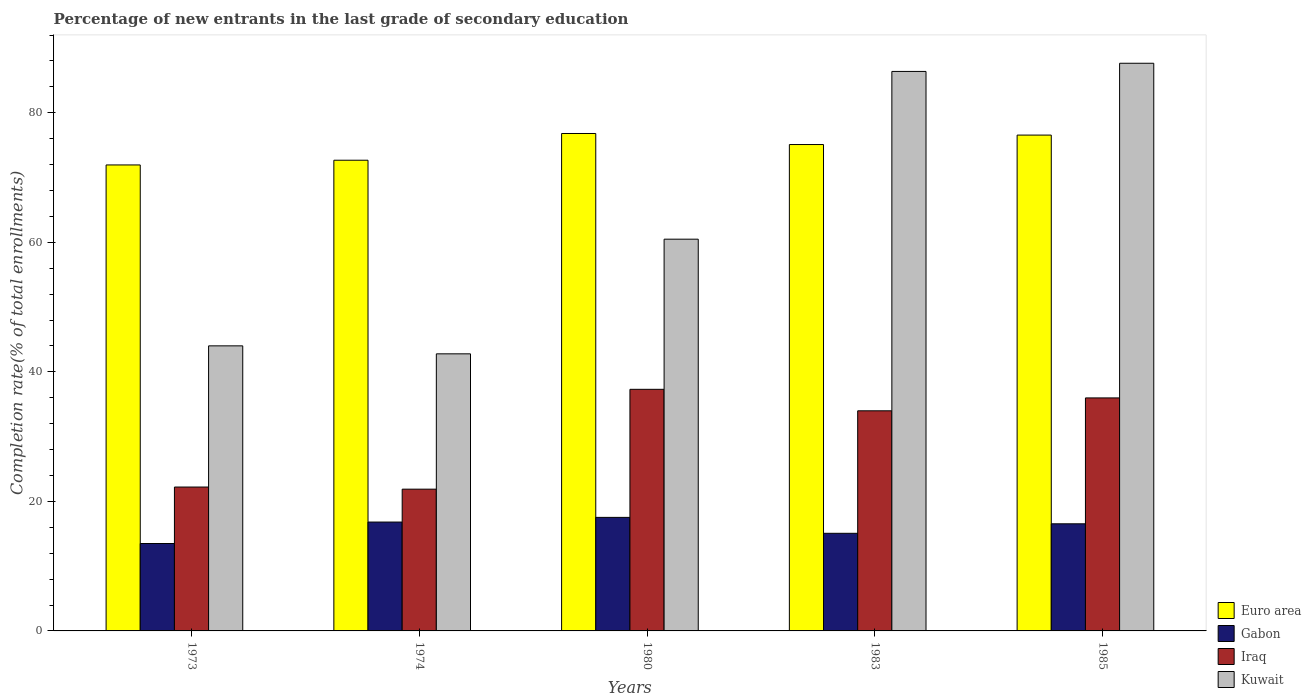How many bars are there on the 2nd tick from the right?
Your answer should be very brief. 4. What is the label of the 1st group of bars from the left?
Give a very brief answer. 1973. What is the percentage of new entrants in Euro area in 1985?
Provide a succinct answer. 76.55. Across all years, what is the maximum percentage of new entrants in Iraq?
Offer a terse response. 37.3. Across all years, what is the minimum percentage of new entrants in Iraq?
Make the answer very short. 21.89. In which year was the percentage of new entrants in Kuwait minimum?
Provide a short and direct response. 1974. What is the total percentage of new entrants in Euro area in the graph?
Give a very brief answer. 373.05. What is the difference between the percentage of new entrants in Euro area in 1980 and that in 1985?
Keep it short and to the point. 0.25. What is the difference between the percentage of new entrants in Kuwait in 1973 and the percentage of new entrants in Iraq in 1974?
Your answer should be compact. 22.13. What is the average percentage of new entrants in Gabon per year?
Your response must be concise. 15.89. In the year 1974, what is the difference between the percentage of new entrants in Iraq and percentage of new entrants in Kuwait?
Provide a short and direct response. -20.89. What is the ratio of the percentage of new entrants in Kuwait in 1973 to that in 1983?
Make the answer very short. 0.51. What is the difference between the highest and the second highest percentage of new entrants in Euro area?
Offer a very short reply. 0.25. What is the difference between the highest and the lowest percentage of new entrants in Gabon?
Your answer should be very brief. 4.03. Is it the case that in every year, the sum of the percentage of new entrants in Kuwait and percentage of new entrants in Euro area is greater than the sum of percentage of new entrants in Iraq and percentage of new entrants in Gabon?
Your answer should be very brief. No. What does the 1st bar from the left in 1985 represents?
Make the answer very short. Euro area. What does the 1st bar from the right in 1980 represents?
Your response must be concise. Kuwait. Is it the case that in every year, the sum of the percentage of new entrants in Iraq and percentage of new entrants in Gabon is greater than the percentage of new entrants in Euro area?
Offer a very short reply. No. How many bars are there?
Make the answer very short. 20. Are all the bars in the graph horizontal?
Provide a short and direct response. No. What is the difference between two consecutive major ticks on the Y-axis?
Provide a succinct answer. 20. Are the values on the major ticks of Y-axis written in scientific E-notation?
Offer a terse response. No. Does the graph contain any zero values?
Give a very brief answer. No. What is the title of the graph?
Your answer should be compact. Percentage of new entrants in the last grade of secondary education. What is the label or title of the Y-axis?
Provide a short and direct response. Completion rate(% of total enrollments). What is the Completion rate(% of total enrollments) in Euro area in 1973?
Offer a very short reply. 71.94. What is the Completion rate(% of total enrollments) of Gabon in 1973?
Give a very brief answer. 13.5. What is the Completion rate(% of total enrollments) in Iraq in 1973?
Keep it short and to the point. 22.21. What is the Completion rate(% of total enrollments) in Kuwait in 1973?
Offer a very short reply. 44.01. What is the Completion rate(% of total enrollments) of Euro area in 1974?
Make the answer very short. 72.67. What is the Completion rate(% of total enrollments) of Gabon in 1974?
Your answer should be very brief. 16.81. What is the Completion rate(% of total enrollments) of Iraq in 1974?
Keep it short and to the point. 21.89. What is the Completion rate(% of total enrollments) in Kuwait in 1974?
Keep it short and to the point. 42.78. What is the Completion rate(% of total enrollments) in Euro area in 1980?
Offer a terse response. 76.8. What is the Completion rate(% of total enrollments) of Gabon in 1980?
Your answer should be compact. 17.53. What is the Completion rate(% of total enrollments) of Iraq in 1980?
Make the answer very short. 37.3. What is the Completion rate(% of total enrollments) of Kuwait in 1980?
Make the answer very short. 60.48. What is the Completion rate(% of total enrollments) in Euro area in 1983?
Ensure brevity in your answer.  75.09. What is the Completion rate(% of total enrollments) in Gabon in 1983?
Your answer should be compact. 15.07. What is the Completion rate(% of total enrollments) in Iraq in 1983?
Offer a very short reply. 33.98. What is the Completion rate(% of total enrollments) of Kuwait in 1983?
Provide a succinct answer. 86.38. What is the Completion rate(% of total enrollments) of Euro area in 1985?
Make the answer very short. 76.55. What is the Completion rate(% of total enrollments) of Gabon in 1985?
Keep it short and to the point. 16.54. What is the Completion rate(% of total enrollments) of Iraq in 1985?
Offer a very short reply. 35.97. What is the Completion rate(% of total enrollments) of Kuwait in 1985?
Ensure brevity in your answer.  87.64. Across all years, what is the maximum Completion rate(% of total enrollments) in Euro area?
Your answer should be very brief. 76.8. Across all years, what is the maximum Completion rate(% of total enrollments) in Gabon?
Offer a terse response. 17.53. Across all years, what is the maximum Completion rate(% of total enrollments) of Iraq?
Offer a very short reply. 37.3. Across all years, what is the maximum Completion rate(% of total enrollments) of Kuwait?
Your response must be concise. 87.64. Across all years, what is the minimum Completion rate(% of total enrollments) in Euro area?
Provide a short and direct response. 71.94. Across all years, what is the minimum Completion rate(% of total enrollments) of Gabon?
Your response must be concise. 13.5. Across all years, what is the minimum Completion rate(% of total enrollments) of Iraq?
Provide a short and direct response. 21.89. Across all years, what is the minimum Completion rate(% of total enrollments) of Kuwait?
Ensure brevity in your answer.  42.78. What is the total Completion rate(% of total enrollments) in Euro area in the graph?
Give a very brief answer. 373.05. What is the total Completion rate(% of total enrollments) in Gabon in the graph?
Give a very brief answer. 79.44. What is the total Completion rate(% of total enrollments) in Iraq in the graph?
Ensure brevity in your answer.  151.36. What is the total Completion rate(% of total enrollments) in Kuwait in the graph?
Your answer should be very brief. 321.29. What is the difference between the Completion rate(% of total enrollments) of Euro area in 1973 and that in 1974?
Make the answer very short. -0.73. What is the difference between the Completion rate(% of total enrollments) of Gabon in 1973 and that in 1974?
Keep it short and to the point. -3.31. What is the difference between the Completion rate(% of total enrollments) in Iraq in 1973 and that in 1974?
Offer a very short reply. 0.33. What is the difference between the Completion rate(% of total enrollments) in Kuwait in 1973 and that in 1974?
Keep it short and to the point. 1.23. What is the difference between the Completion rate(% of total enrollments) of Euro area in 1973 and that in 1980?
Make the answer very short. -4.86. What is the difference between the Completion rate(% of total enrollments) in Gabon in 1973 and that in 1980?
Offer a terse response. -4.03. What is the difference between the Completion rate(% of total enrollments) of Iraq in 1973 and that in 1980?
Your answer should be very brief. -15.09. What is the difference between the Completion rate(% of total enrollments) of Kuwait in 1973 and that in 1980?
Your response must be concise. -16.47. What is the difference between the Completion rate(% of total enrollments) in Euro area in 1973 and that in 1983?
Provide a succinct answer. -3.15. What is the difference between the Completion rate(% of total enrollments) of Gabon in 1973 and that in 1983?
Your response must be concise. -1.58. What is the difference between the Completion rate(% of total enrollments) of Iraq in 1973 and that in 1983?
Offer a very short reply. -11.77. What is the difference between the Completion rate(% of total enrollments) of Kuwait in 1973 and that in 1983?
Make the answer very short. -42.37. What is the difference between the Completion rate(% of total enrollments) of Euro area in 1973 and that in 1985?
Make the answer very short. -4.61. What is the difference between the Completion rate(% of total enrollments) of Gabon in 1973 and that in 1985?
Offer a very short reply. -3.04. What is the difference between the Completion rate(% of total enrollments) in Iraq in 1973 and that in 1985?
Ensure brevity in your answer.  -13.76. What is the difference between the Completion rate(% of total enrollments) in Kuwait in 1973 and that in 1985?
Provide a short and direct response. -43.63. What is the difference between the Completion rate(% of total enrollments) in Euro area in 1974 and that in 1980?
Your answer should be compact. -4.13. What is the difference between the Completion rate(% of total enrollments) of Gabon in 1974 and that in 1980?
Offer a terse response. -0.72. What is the difference between the Completion rate(% of total enrollments) of Iraq in 1974 and that in 1980?
Give a very brief answer. -15.42. What is the difference between the Completion rate(% of total enrollments) in Kuwait in 1974 and that in 1980?
Offer a terse response. -17.7. What is the difference between the Completion rate(% of total enrollments) of Euro area in 1974 and that in 1983?
Keep it short and to the point. -2.42. What is the difference between the Completion rate(% of total enrollments) of Gabon in 1974 and that in 1983?
Keep it short and to the point. 1.74. What is the difference between the Completion rate(% of total enrollments) of Iraq in 1974 and that in 1983?
Your answer should be compact. -12.1. What is the difference between the Completion rate(% of total enrollments) of Kuwait in 1974 and that in 1983?
Offer a terse response. -43.6. What is the difference between the Completion rate(% of total enrollments) of Euro area in 1974 and that in 1985?
Your answer should be very brief. -3.88. What is the difference between the Completion rate(% of total enrollments) in Gabon in 1974 and that in 1985?
Provide a succinct answer. 0.27. What is the difference between the Completion rate(% of total enrollments) of Iraq in 1974 and that in 1985?
Keep it short and to the point. -14.09. What is the difference between the Completion rate(% of total enrollments) of Kuwait in 1974 and that in 1985?
Make the answer very short. -44.86. What is the difference between the Completion rate(% of total enrollments) of Euro area in 1980 and that in 1983?
Offer a very short reply. 1.71. What is the difference between the Completion rate(% of total enrollments) in Gabon in 1980 and that in 1983?
Your answer should be compact. 2.46. What is the difference between the Completion rate(% of total enrollments) of Iraq in 1980 and that in 1983?
Offer a terse response. 3.32. What is the difference between the Completion rate(% of total enrollments) in Kuwait in 1980 and that in 1983?
Give a very brief answer. -25.9. What is the difference between the Completion rate(% of total enrollments) of Euro area in 1980 and that in 1985?
Make the answer very short. 0.25. What is the difference between the Completion rate(% of total enrollments) of Gabon in 1980 and that in 1985?
Your answer should be very brief. 0.99. What is the difference between the Completion rate(% of total enrollments) in Iraq in 1980 and that in 1985?
Provide a short and direct response. 1.33. What is the difference between the Completion rate(% of total enrollments) in Kuwait in 1980 and that in 1985?
Provide a short and direct response. -27.16. What is the difference between the Completion rate(% of total enrollments) of Euro area in 1983 and that in 1985?
Give a very brief answer. -1.46. What is the difference between the Completion rate(% of total enrollments) in Gabon in 1983 and that in 1985?
Your response must be concise. -1.47. What is the difference between the Completion rate(% of total enrollments) in Iraq in 1983 and that in 1985?
Offer a terse response. -1.99. What is the difference between the Completion rate(% of total enrollments) in Kuwait in 1983 and that in 1985?
Make the answer very short. -1.26. What is the difference between the Completion rate(% of total enrollments) of Euro area in 1973 and the Completion rate(% of total enrollments) of Gabon in 1974?
Provide a short and direct response. 55.13. What is the difference between the Completion rate(% of total enrollments) of Euro area in 1973 and the Completion rate(% of total enrollments) of Iraq in 1974?
Your answer should be very brief. 50.06. What is the difference between the Completion rate(% of total enrollments) in Euro area in 1973 and the Completion rate(% of total enrollments) in Kuwait in 1974?
Make the answer very short. 29.16. What is the difference between the Completion rate(% of total enrollments) in Gabon in 1973 and the Completion rate(% of total enrollments) in Iraq in 1974?
Ensure brevity in your answer.  -8.39. What is the difference between the Completion rate(% of total enrollments) in Gabon in 1973 and the Completion rate(% of total enrollments) in Kuwait in 1974?
Provide a succinct answer. -29.28. What is the difference between the Completion rate(% of total enrollments) of Iraq in 1973 and the Completion rate(% of total enrollments) of Kuwait in 1974?
Provide a succinct answer. -20.57. What is the difference between the Completion rate(% of total enrollments) in Euro area in 1973 and the Completion rate(% of total enrollments) in Gabon in 1980?
Your response must be concise. 54.41. What is the difference between the Completion rate(% of total enrollments) of Euro area in 1973 and the Completion rate(% of total enrollments) of Iraq in 1980?
Offer a very short reply. 34.64. What is the difference between the Completion rate(% of total enrollments) in Euro area in 1973 and the Completion rate(% of total enrollments) in Kuwait in 1980?
Make the answer very short. 11.46. What is the difference between the Completion rate(% of total enrollments) in Gabon in 1973 and the Completion rate(% of total enrollments) in Iraq in 1980?
Make the answer very short. -23.81. What is the difference between the Completion rate(% of total enrollments) of Gabon in 1973 and the Completion rate(% of total enrollments) of Kuwait in 1980?
Provide a short and direct response. -46.99. What is the difference between the Completion rate(% of total enrollments) of Iraq in 1973 and the Completion rate(% of total enrollments) of Kuwait in 1980?
Offer a very short reply. -38.27. What is the difference between the Completion rate(% of total enrollments) of Euro area in 1973 and the Completion rate(% of total enrollments) of Gabon in 1983?
Offer a terse response. 56.87. What is the difference between the Completion rate(% of total enrollments) of Euro area in 1973 and the Completion rate(% of total enrollments) of Iraq in 1983?
Keep it short and to the point. 37.96. What is the difference between the Completion rate(% of total enrollments) of Euro area in 1973 and the Completion rate(% of total enrollments) of Kuwait in 1983?
Give a very brief answer. -14.44. What is the difference between the Completion rate(% of total enrollments) in Gabon in 1973 and the Completion rate(% of total enrollments) in Iraq in 1983?
Your answer should be very brief. -20.49. What is the difference between the Completion rate(% of total enrollments) of Gabon in 1973 and the Completion rate(% of total enrollments) of Kuwait in 1983?
Ensure brevity in your answer.  -72.88. What is the difference between the Completion rate(% of total enrollments) of Iraq in 1973 and the Completion rate(% of total enrollments) of Kuwait in 1983?
Give a very brief answer. -64.17. What is the difference between the Completion rate(% of total enrollments) in Euro area in 1973 and the Completion rate(% of total enrollments) in Gabon in 1985?
Offer a terse response. 55.4. What is the difference between the Completion rate(% of total enrollments) of Euro area in 1973 and the Completion rate(% of total enrollments) of Iraq in 1985?
Provide a short and direct response. 35.97. What is the difference between the Completion rate(% of total enrollments) in Euro area in 1973 and the Completion rate(% of total enrollments) in Kuwait in 1985?
Your answer should be compact. -15.7. What is the difference between the Completion rate(% of total enrollments) in Gabon in 1973 and the Completion rate(% of total enrollments) in Iraq in 1985?
Give a very brief answer. -22.48. What is the difference between the Completion rate(% of total enrollments) of Gabon in 1973 and the Completion rate(% of total enrollments) of Kuwait in 1985?
Ensure brevity in your answer.  -74.14. What is the difference between the Completion rate(% of total enrollments) of Iraq in 1973 and the Completion rate(% of total enrollments) of Kuwait in 1985?
Keep it short and to the point. -65.43. What is the difference between the Completion rate(% of total enrollments) of Euro area in 1974 and the Completion rate(% of total enrollments) of Gabon in 1980?
Provide a succinct answer. 55.14. What is the difference between the Completion rate(% of total enrollments) of Euro area in 1974 and the Completion rate(% of total enrollments) of Iraq in 1980?
Provide a succinct answer. 35.37. What is the difference between the Completion rate(% of total enrollments) of Euro area in 1974 and the Completion rate(% of total enrollments) of Kuwait in 1980?
Provide a succinct answer. 12.19. What is the difference between the Completion rate(% of total enrollments) in Gabon in 1974 and the Completion rate(% of total enrollments) in Iraq in 1980?
Offer a very short reply. -20.49. What is the difference between the Completion rate(% of total enrollments) of Gabon in 1974 and the Completion rate(% of total enrollments) of Kuwait in 1980?
Ensure brevity in your answer.  -43.67. What is the difference between the Completion rate(% of total enrollments) of Iraq in 1974 and the Completion rate(% of total enrollments) of Kuwait in 1980?
Your response must be concise. -38.59. What is the difference between the Completion rate(% of total enrollments) of Euro area in 1974 and the Completion rate(% of total enrollments) of Gabon in 1983?
Offer a very short reply. 57.6. What is the difference between the Completion rate(% of total enrollments) in Euro area in 1974 and the Completion rate(% of total enrollments) in Iraq in 1983?
Give a very brief answer. 38.69. What is the difference between the Completion rate(% of total enrollments) in Euro area in 1974 and the Completion rate(% of total enrollments) in Kuwait in 1983?
Your response must be concise. -13.71. What is the difference between the Completion rate(% of total enrollments) in Gabon in 1974 and the Completion rate(% of total enrollments) in Iraq in 1983?
Your answer should be compact. -17.18. What is the difference between the Completion rate(% of total enrollments) in Gabon in 1974 and the Completion rate(% of total enrollments) in Kuwait in 1983?
Keep it short and to the point. -69.57. What is the difference between the Completion rate(% of total enrollments) of Iraq in 1974 and the Completion rate(% of total enrollments) of Kuwait in 1983?
Keep it short and to the point. -64.49. What is the difference between the Completion rate(% of total enrollments) in Euro area in 1974 and the Completion rate(% of total enrollments) in Gabon in 1985?
Your answer should be very brief. 56.13. What is the difference between the Completion rate(% of total enrollments) of Euro area in 1974 and the Completion rate(% of total enrollments) of Iraq in 1985?
Your answer should be very brief. 36.7. What is the difference between the Completion rate(% of total enrollments) in Euro area in 1974 and the Completion rate(% of total enrollments) in Kuwait in 1985?
Your answer should be very brief. -14.97. What is the difference between the Completion rate(% of total enrollments) of Gabon in 1974 and the Completion rate(% of total enrollments) of Iraq in 1985?
Give a very brief answer. -19.16. What is the difference between the Completion rate(% of total enrollments) of Gabon in 1974 and the Completion rate(% of total enrollments) of Kuwait in 1985?
Offer a terse response. -70.83. What is the difference between the Completion rate(% of total enrollments) of Iraq in 1974 and the Completion rate(% of total enrollments) of Kuwait in 1985?
Your answer should be very brief. -65.75. What is the difference between the Completion rate(% of total enrollments) of Euro area in 1980 and the Completion rate(% of total enrollments) of Gabon in 1983?
Ensure brevity in your answer.  61.73. What is the difference between the Completion rate(% of total enrollments) of Euro area in 1980 and the Completion rate(% of total enrollments) of Iraq in 1983?
Ensure brevity in your answer.  42.81. What is the difference between the Completion rate(% of total enrollments) of Euro area in 1980 and the Completion rate(% of total enrollments) of Kuwait in 1983?
Provide a short and direct response. -9.58. What is the difference between the Completion rate(% of total enrollments) of Gabon in 1980 and the Completion rate(% of total enrollments) of Iraq in 1983?
Give a very brief answer. -16.45. What is the difference between the Completion rate(% of total enrollments) in Gabon in 1980 and the Completion rate(% of total enrollments) in Kuwait in 1983?
Ensure brevity in your answer.  -68.85. What is the difference between the Completion rate(% of total enrollments) in Iraq in 1980 and the Completion rate(% of total enrollments) in Kuwait in 1983?
Your answer should be compact. -49.08. What is the difference between the Completion rate(% of total enrollments) in Euro area in 1980 and the Completion rate(% of total enrollments) in Gabon in 1985?
Make the answer very short. 60.26. What is the difference between the Completion rate(% of total enrollments) of Euro area in 1980 and the Completion rate(% of total enrollments) of Iraq in 1985?
Your response must be concise. 40.82. What is the difference between the Completion rate(% of total enrollments) of Euro area in 1980 and the Completion rate(% of total enrollments) of Kuwait in 1985?
Your answer should be very brief. -10.84. What is the difference between the Completion rate(% of total enrollments) in Gabon in 1980 and the Completion rate(% of total enrollments) in Iraq in 1985?
Keep it short and to the point. -18.44. What is the difference between the Completion rate(% of total enrollments) of Gabon in 1980 and the Completion rate(% of total enrollments) of Kuwait in 1985?
Your answer should be very brief. -70.11. What is the difference between the Completion rate(% of total enrollments) of Iraq in 1980 and the Completion rate(% of total enrollments) of Kuwait in 1985?
Keep it short and to the point. -50.34. What is the difference between the Completion rate(% of total enrollments) of Euro area in 1983 and the Completion rate(% of total enrollments) of Gabon in 1985?
Give a very brief answer. 58.55. What is the difference between the Completion rate(% of total enrollments) in Euro area in 1983 and the Completion rate(% of total enrollments) in Iraq in 1985?
Your response must be concise. 39.12. What is the difference between the Completion rate(% of total enrollments) in Euro area in 1983 and the Completion rate(% of total enrollments) in Kuwait in 1985?
Your answer should be compact. -12.55. What is the difference between the Completion rate(% of total enrollments) in Gabon in 1983 and the Completion rate(% of total enrollments) in Iraq in 1985?
Give a very brief answer. -20.9. What is the difference between the Completion rate(% of total enrollments) of Gabon in 1983 and the Completion rate(% of total enrollments) of Kuwait in 1985?
Give a very brief answer. -72.57. What is the difference between the Completion rate(% of total enrollments) of Iraq in 1983 and the Completion rate(% of total enrollments) of Kuwait in 1985?
Offer a terse response. -53.66. What is the average Completion rate(% of total enrollments) in Euro area per year?
Offer a terse response. 74.61. What is the average Completion rate(% of total enrollments) in Gabon per year?
Offer a terse response. 15.89. What is the average Completion rate(% of total enrollments) in Iraq per year?
Give a very brief answer. 30.27. What is the average Completion rate(% of total enrollments) in Kuwait per year?
Make the answer very short. 64.26. In the year 1973, what is the difference between the Completion rate(% of total enrollments) in Euro area and Completion rate(% of total enrollments) in Gabon?
Provide a short and direct response. 58.45. In the year 1973, what is the difference between the Completion rate(% of total enrollments) of Euro area and Completion rate(% of total enrollments) of Iraq?
Your answer should be very brief. 49.73. In the year 1973, what is the difference between the Completion rate(% of total enrollments) of Euro area and Completion rate(% of total enrollments) of Kuwait?
Provide a short and direct response. 27.93. In the year 1973, what is the difference between the Completion rate(% of total enrollments) in Gabon and Completion rate(% of total enrollments) in Iraq?
Make the answer very short. -8.72. In the year 1973, what is the difference between the Completion rate(% of total enrollments) of Gabon and Completion rate(% of total enrollments) of Kuwait?
Your answer should be very brief. -30.52. In the year 1973, what is the difference between the Completion rate(% of total enrollments) of Iraq and Completion rate(% of total enrollments) of Kuwait?
Give a very brief answer. -21.8. In the year 1974, what is the difference between the Completion rate(% of total enrollments) in Euro area and Completion rate(% of total enrollments) in Gabon?
Provide a succinct answer. 55.86. In the year 1974, what is the difference between the Completion rate(% of total enrollments) in Euro area and Completion rate(% of total enrollments) in Iraq?
Give a very brief answer. 50.78. In the year 1974, what is the difference between the Completion rate(% of total enrollments) of Euro area and Completion rate(% of total enrollments) of Kuwait?
Make the answer very short. 29.89. In the year 1974, what is the difference between the Completion rate(% of total enrollments) of Gabon and Completion rate(% of total enrollments) of Iraq?
Ensure brevity in your answer.  -5.08. In the year 1974, what is the difference between the Completion rate(% of total enrollments) in Gabon and Completion rate(% of total enrollments) in Kuwait?
Keep it short and to the point. -25.97. In the year 1974, what is the difference between the Completion rate(% of total enrollments) of Iraq and Completion rate(% of total enrollments) of Kuwait?
Offer a terse response. -20.89. In the year 1980, what is the difference between the Completion rate(% of total enrollments) in Euro area and Completion rate(% of total enrollments) in Gabon?
Provide a short and direct response. 59.27. In the year 1980, what is the difference between the Completion rate(% of total enrollments) in Euro area and Completion rate(% of total enrollments) in Iraq?
Give a very brief answer. 39.5. In the year 1980, what is the difference between the Completion rate(% of total enrollments) in Euro area and Completion rate(% of total enrollments) in Kuwait?
Keep it short and to the point. 16.32. In the year 1980, what is the difference between the Completion rate(% of total enrollments) in Gabon and Completion rate(% of total enrollments) in Iraq?
Ensure brevity in your answer.  -19.77. In the year 1980, what is the difference between the Completion rate(% of total enrollments) in Gabon and Completion rate(% of total enrollments) in Kuwait?
Make the answer very short. -42.95. In the year 1980, what is the difference between the Completion rate(% of total enrollments) of Iraq and Completion rate(% of total enrollments) of Kuwait?
Offer a very short reply. -23.18. In the year 1983, what is the difference between the Completion rate(% of total enrollments) of Euro area and Completion rate(% of total enrollments) of Gabon?
Ensure brevity in your answer.  60.02. In the year 1983, what is the difference between the Completion rate(% of total enrollments) in Euro area and Completion rate(% of total enrollments) in Iraq?
Your answer should be very brief. 41.11. In the year 1983, what is the difference between the Completion rate(% of total enrollments) in Euro area and Completion rate(% of total enrollments) in Kuwait?
Provide a succinct answer. -11.29. In the year 1983, what is the difference between the Completion rate(% of total enrollments) in Gabon and Completion rate(% of total enrollments) in Iraq?
Provide a succinct answer. -18.91. In the year 1983, what is the difference between the Completion rate(% of total enrollments) of Gabon and Completion rate(% of total enrollments) of Kuwait?
Give a very brief answer. -71.31. In the year 1983, what is the difference between the Completion rate(% of total enrollments) in Iraq and Completion rate(% of total enrollments) in Kuwait?
Keep it short and to the point. -52.4. In the year 1985, what is the difference between the Completion rate(% of total enrollments) in Euro area and Completion rate(% of total enrollments) in Gabon?
Your answer should be compact. 60.01. In the year 1985, what is the difference between the Completion rate(% of total enrollments) in Euro area and Completion rate(% of total enrollments) in Iraq?
Make the answer very short. 40.58. In the year 1985, what is the difference between the Completion rate(% of total enrollments) in Euro area and Completion rate(% of total enrollments) in Kuwait?
Offer a very short reply. -11.09. In the year 1985, what is the difference between the Completion rate(% of total enrollments) of Gabon and Completion rate(% of total enrollments) of Iraq?
Offer a very short reply. -19.44. In the year 1985, what is the difference between the Completion rate(% of total enrollments) in Gabon and Completion rate(% of total enrollments) in Kuwait?
Offer a terse response. -71.1. In the year 1985, what is the difference between the Completion rate(% of total enrollments) in Iraq and Completion rate(% of total enrollments) in Kuwait?
Ensure brevity in your answer.  -51.67. What is the ratio of the Completion rate(% of total enrollments) in Gabon in 1973 to that in 1974?
Provide a short and direct response. 0.8. What is the ratio of the Completion rate(% of total enrollments) of Iraq in 1973 to that in 1974?
Your response must be concise. 1.01. What is the ratio of the Completion rate(% of total enrollments) in Kuwait in 1973 to that in 1974?
Your response must be concise. 1.03. What is the ratio of the Completion rate(% of total enrollments) of Euro area in 1973 to that in 1980?
Your answer should be very brief. 0.94. What is the ratio of the Completion rate(% of total enrollments) of Gabon in 1973 to that in 1980?
Give a very brief answer. 0.77. What is the ratio of the Completion rate(% of total enrollments) in Iraq in 1973 to that in 1980?
Your response must be concise. 0.6. What is the ratio of the Completion rate(% of total enrollments) of Kuwait in 1973 to that in 1980?
Give a very brief answer. 0.73. What is the ratio of the Completion rate(% of total enrollments) of Euro area in 1973 to that in 1983?
Your answer should be very brief. 0.96. What is the ratio of the Completion rate(% of total enrollments) of Gabon in 1973 to that in 1983?
Your response must be concise. 0.9. What is the ratio of the Completion rate(% of total enrollments) of Iraq in 1973 to that in 1983?
Offer a terse response. 0.65. What is the ratio of the Completion rate(% of total enrollments) in Kuwait in 1973 to that in 1983?
Your answer should be compact. 0.51. What is the ratio of the Completion rate(% of total enrollments) in Euro area in 1973 to that in 1985?
Provide a short and direct response. 0.94. What is the ratio of the Completion rate(% of total enrollments) of Gabon in 1973 to that in 1985?
Provide a succinct answer. 0.82. What is the ratio of the Completion rate(% of total enrollments) of Iraq in 1973 to that in 1985?
Make the answer very short. 0.62. What is the ratio of the Completion rate(% of total enrollments) of Kuwait in 1973 to that in 1985?
Ensure brevity in your answer.  0.5. What is the ratio of the Completion rate(% of total enrollments) in Euro area in 1974 to that in 1980?
Offer a very short reply. 0.95. What is the ratio of the Completion rate(% of total enrollments) in Gabon in 1974 to that in 1980?
Provide a succinct answer. 0.96. What is the ratio of the Completion rate(% of total enrollments) of Iraq in 1974 to that in 1980?
Ensure brevity in your answer.  0.59. What is the ratio of the Completion rate(% of total enrollments) in Kuwait in 1974 to that in 1980?
Your answer should be compact. 0.71. What is the ratio of the Completion rate(% of total enrollments) of Euro area in 1974 to that in 1983?
Provide a short and direct response. 0.97. What is the ratio of the Completion rate(% of total enrollments) in Gabon in 1974 to that in 1983?
Provide a succinct answer. 1.12. What is the ratio of the Completion rate(% of total enrollments) in Iraq in 1974 to that in 1983?
Provide a short and direct response. 0.64. What is the ratio of the Completion rate(% of total enrollments) in Kuwait in 1974 to that in 1983?
Provide a short and direct response. 0.5. What is the ratio of the Completion rate(% of total enrollments) in Euro area in 1974 to that in 1985?
Offer a terse response. 0.95. What is the ratio of the Completion rate(% of total enrollments) in Gabon in 1974 to that in 1985?
Your response must be concise. 1.02. What is the ratio of the Completion rate(% of total enrollments) of Iraq in 1974 to that in 1985?
Your response must be concise. 0.61. What is the ratio of the Completion rate(% of total enrollments) in Kuwait in 1974 to that in 1985?
Give a very brief answer. 0.49. What is the ratio of the Completion rate(% of total enrollments) of Euro area in 1980 to that in 1983?
Your answer should be very brief. 1.02. What is the ratio of the Completion rate(% of total enrollments) in Gabon in 1980 to that in 1983?
Provide a succinct answer. 1.16. What is the ratio of the Completion rate(% of total enrollments) of Iraq in 1980 to that in 1983?
Your response must be concise. 1.1. What is the ratio of the Completion rate(% of total enrollments) in Kuwait in 1980 to that in 1983?
Offer a terse response. 0.7. What is the ratio of the Completion rate(% of total enrollments) of Gabon in 1980 to that in 1985?
Offer a very short reply. 1.06. What is the ratio of the Completion rate(% of total enrollments) of Iraq in 1980 to that in 1985?
Ensure brevity in your answer.  1.04. What is the ratio of the Completion rate(% of total enrollments) in Kuwait in 1980 to that in 1985?
Make the answer very short. 0.69. What is the ratio of the Completion rate(% of total enrollments) of Euro area in 1983 to that in 1985?
Offer a terse response. 0.98. What is the ratio of the Completion rate(% of total enrollments) of Gabon in 1983 to that in 1985?
Your response must be concise. 0.91. What is the ratio of the Completion rate(% of total enrollments) of Iraq in 1983 to that in 1985?
Ensure brevity in your answer.  0.94. What is the ratio of the Completion rate(% of total enrollments) in Kuwait in 1983 to that in 1985?
Give a very brief answer. 0.99. What is the difference between the highest and the second highest Completion rate(% of total enrollments) of Euro area?
Your response must be concise. 0.25. What is the difference between the highest and the second highest Completion rate(% of total enrollments) in Gabon?
Give a very brief answer. 0.72. What is the difference between the highest and the second highest Completion rate(% of total enrollments) in Iraq?
Offer a terse response. 1.33. What is the difference between the highest and the second highest Completion rate(% of total enrollments) of Kuwait?
Provide a succinct answer. 1.26. What is the difference between the highest and the lowest Completion rate(% of total enrollments) in Euro area?
Provide a succinct answer. 4.86. What is the difference between the highest and the lowest Completion rate(% of total enrollments) of Gabon?
Make the answer very short. 4.03. What is the difference between the highest and the lowest Completion rate(% of total enrollments) of Iraq?
Your response must be concise. 15.42. What is the difference between the highest and the lowest Completion rate(% of total enrollments) in Kuwait?
Your response must be concise. 44.86. 